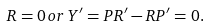<formula> <loc_0><loc_0><loc_500><loc_500>R = 0 \, o r \, Y ^ { \prime } = P R ^ { \prime } - R P ^ { \prime } = 0 .</formula> 